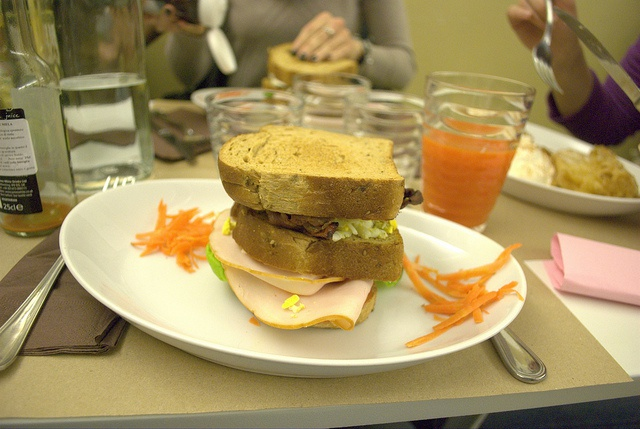Describe the objects in this image and their specific colors. I can see dining table in olive and tan tones, sandwich in olive and gold tones, cup in olive, tan, and red tones, people in olive, tan, and gray tones, and bottle in olive and black tones in this image. 